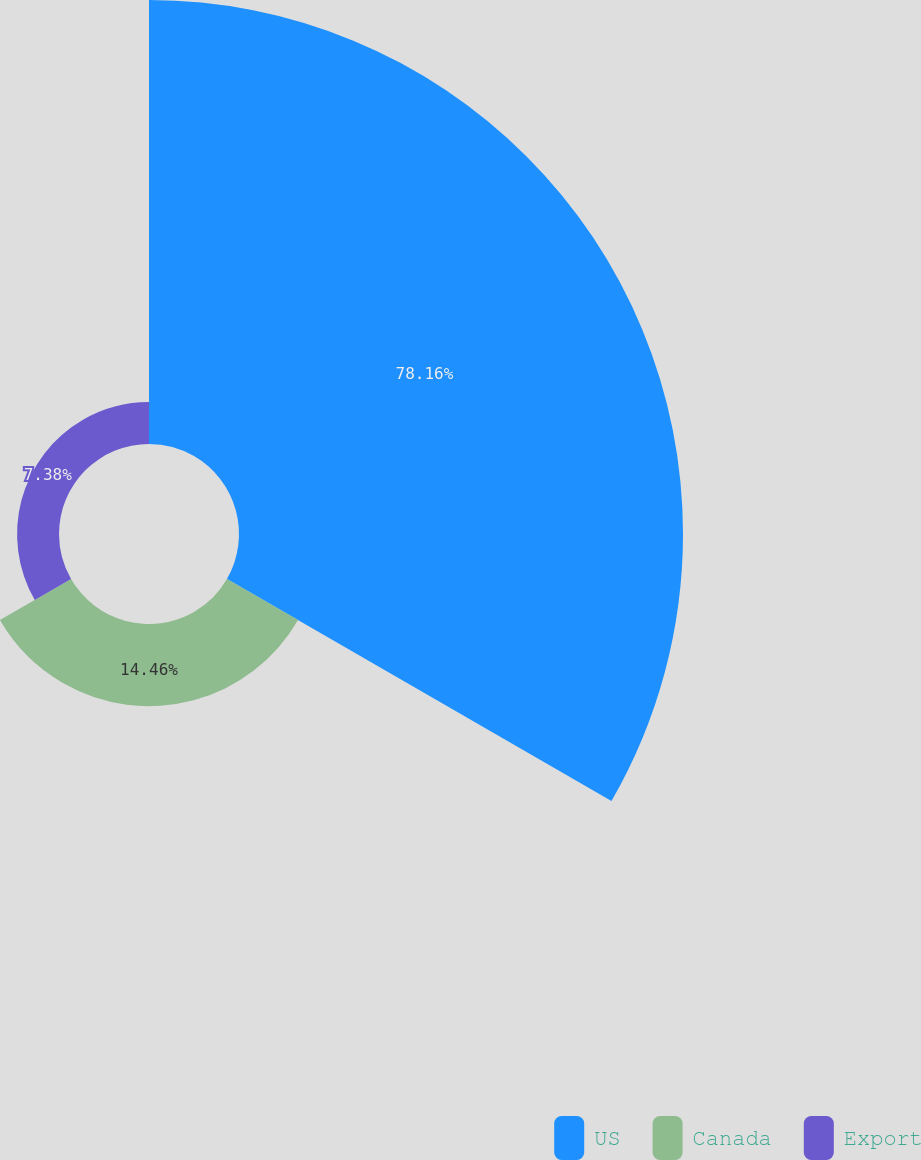<chart> <loc_0><loc_0><loc_500><loc_500><pie_chart><fcel>US<fcel>Canada<fcel>Export<nl><fcel>78.16%<fcel>14.46%<fcel>7.38%<nl></chart> 